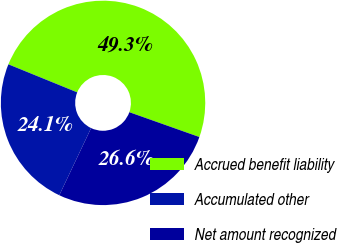<chart> <loc_0><loc_0><loc_500><loc_500><pie_chart><fcel>Accrued benefit liability<fcel>Accumulated other<fcel>Net amount recognized<nl><fcel>49.27%<fcel>24.11%<fcel>26.62%<nl></chart> 